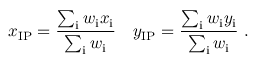Convert formula to latex. <formula><loc_0><loc_0><loc_500><loc_500>x _ { I P } = \frac { \sum _ { i } w _ { i } x _ { i } } { \sum _ { i } w _ { i } } \ \ \ y _ { I P } = \frac { \sum _ { i } w _ { i } y _ { i } } { \sum _ { i } w _ { i } } .</formula> 